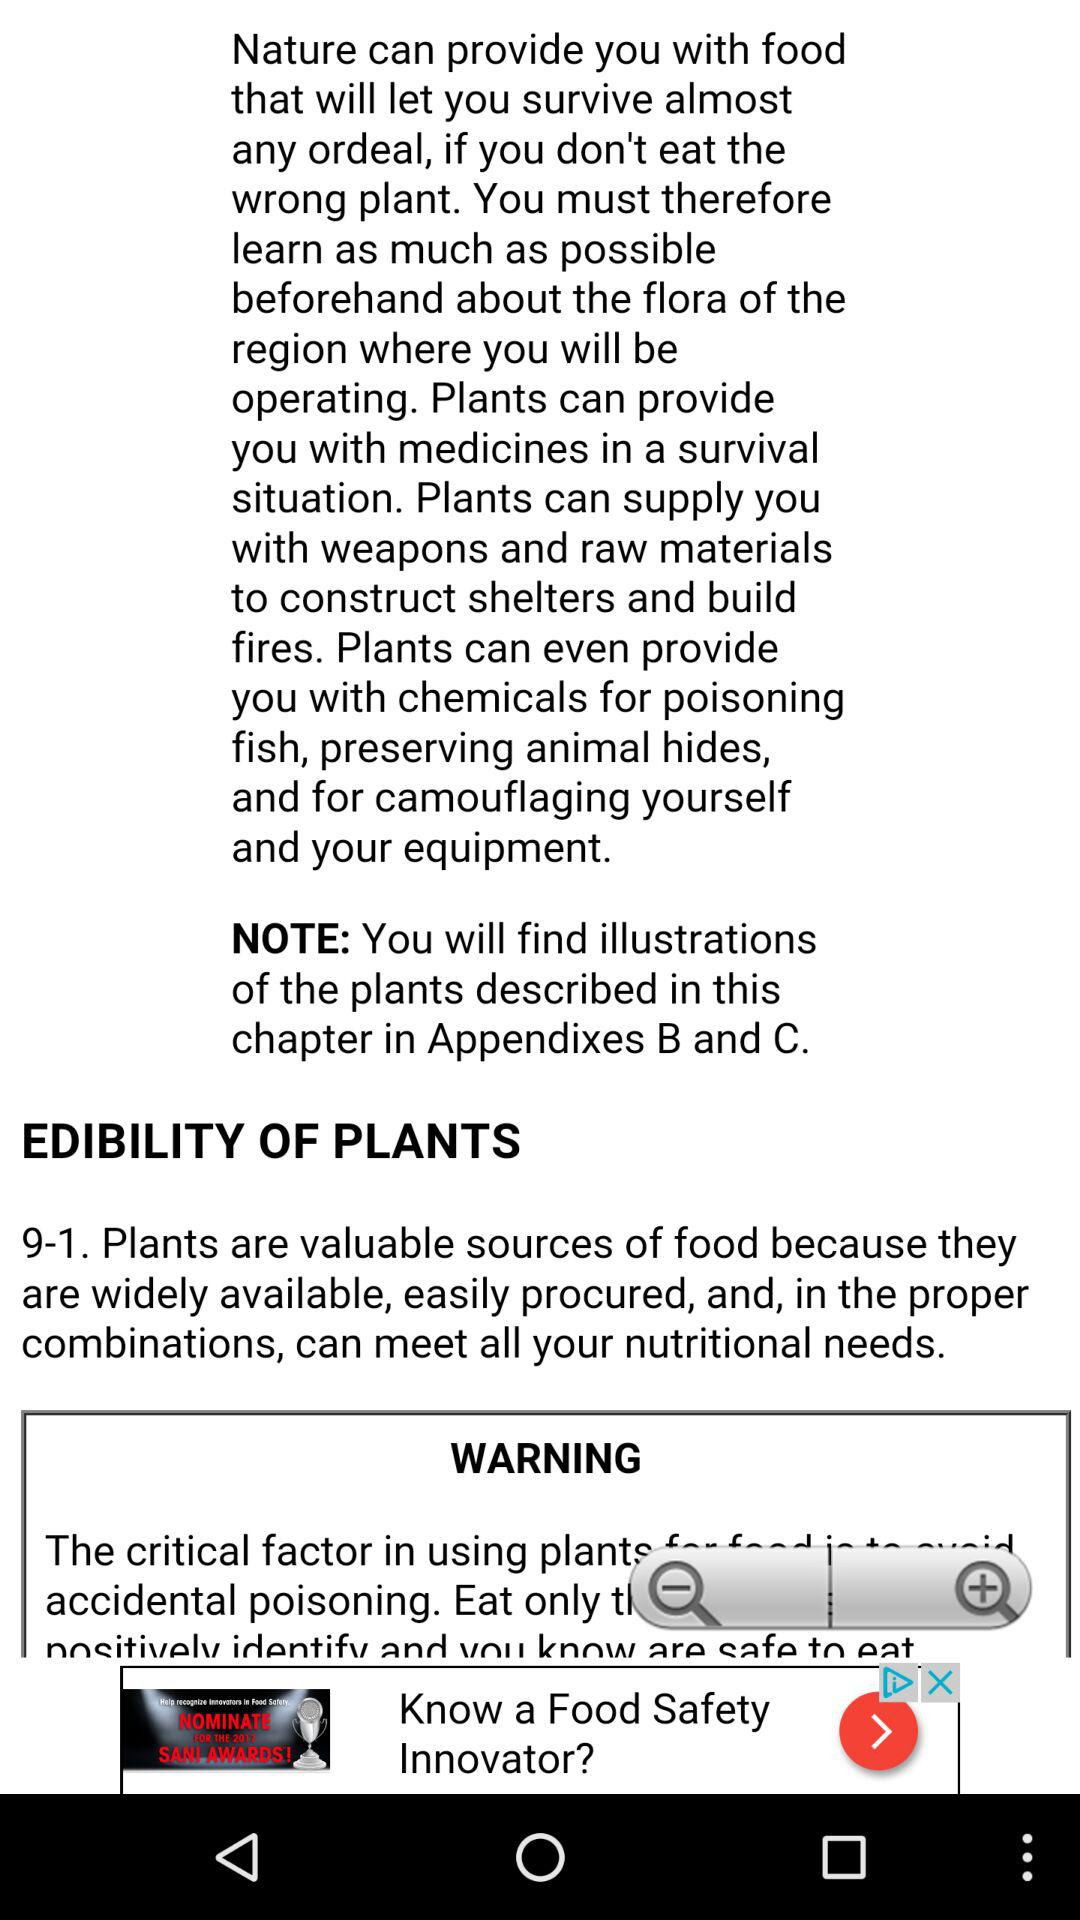How many magnifying glasses are there on the screen?
Answer the question using a single word or phrase. 2 